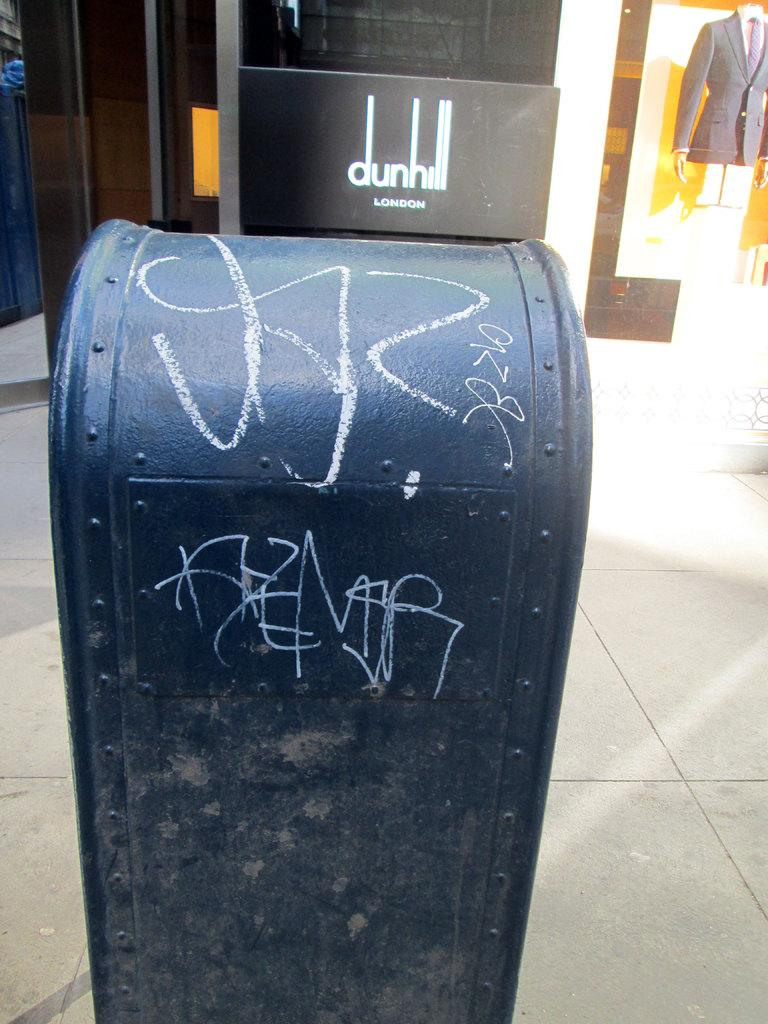<image>
Render a clear and concise summary of the photo. Black sign which says LONDON above a mailbox. 